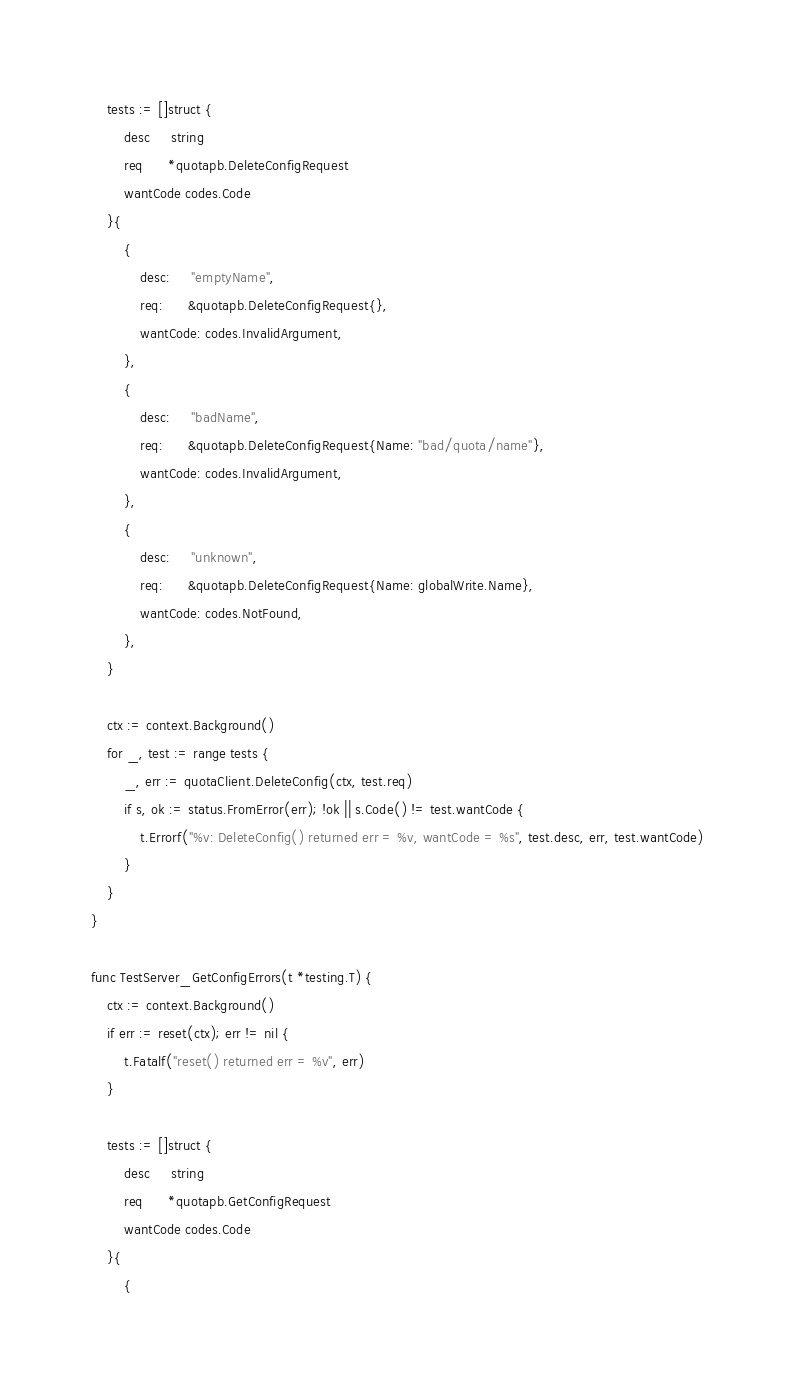<code> <loc_0><loc_0><loc_500><loc_500><_Go_>	tests := []struct {
		desc     string
		req      *quotapb.DeleteConfigRequest
		wantCode codes.Code
	}{
		{
			desc:     "emptyName",
			req:      &quotapb.DeleteConfigRequest{},
			wantCode: codes.InvalidArgument,
		},
		{
			desc:     "badName",
			req:      &quotapb.DeleteConfigRequest{Name: "bad/quota/name"},
			wantCode: codes.InvalidArgument,
		},
		{
			desc:     "unknown",
			req:      &quotapb.DeleteConfigRequest{Name: globalWrite.Name},
			wantCode: codes.NotFound,
		},
	}

	ctx := context.Background()
	for _, test := range tests {
		_, err := quotaClient.DeleteConfig(ctx, test.req)
		if s, ok := status.FromError(err); !ok || s.Code() != test.wantCode {
			t.Errorf("%v: DeleteConfig() returned err = %v, wantCode = %s", test.desc, err, test.wantCode)
		}
	}
}

func TestServer_GetConfigErrors(t *testing.T) {
	ctx := context.Background()
	if err := reset(ctx); err != nil {
		t.Fatalf("reset() returned err = %v", err)
	}

	tests := []struct {
		desc     string
		req      *quotapb.GetConfigRequest
		wantCode codes.Code
	}{
		{</code> 